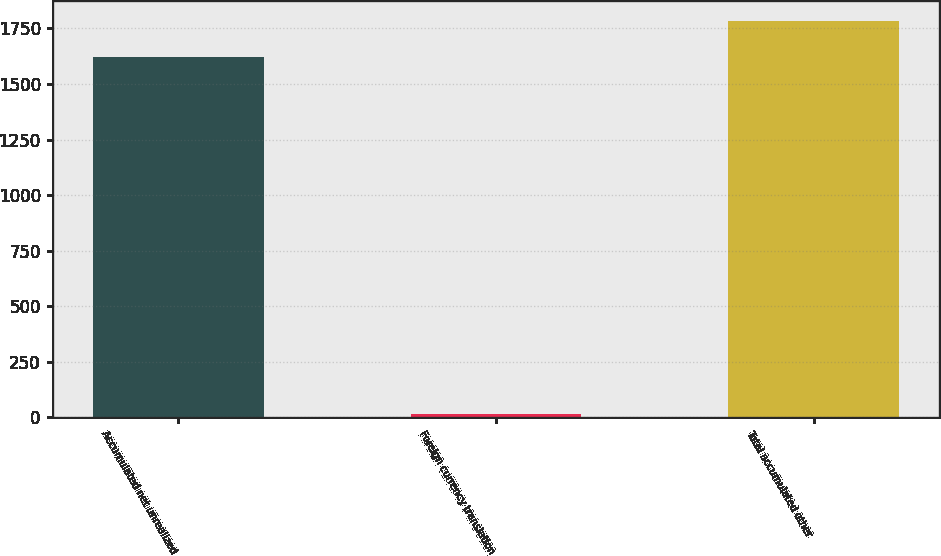Convert chart. <chart><loc_0><loc_0><loc_500><loc_500><bar_chart><fcel>Accumulated net unrealized<fcel>Foreign currency translation<fcel>Total accumulated other<nl><fcel>1623<fcel>15<fcel>1785.3<nl></chart> 